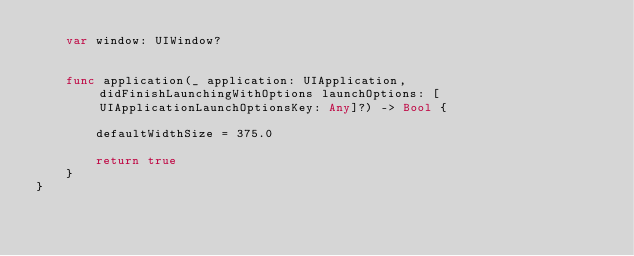Convert code to text. <code><loc_0><loc_0><loc_500><loc_500><_Swift_>    var window: UIWindow?


    func application(_ application: UIApplication, didFinishLaunchingWithOptions launchOptions: [UIApplicationLaunchOptionsKey: Any]?) -> Bool {

        defaultWidthSize = 375.0

        return true
    }
}
</code> 